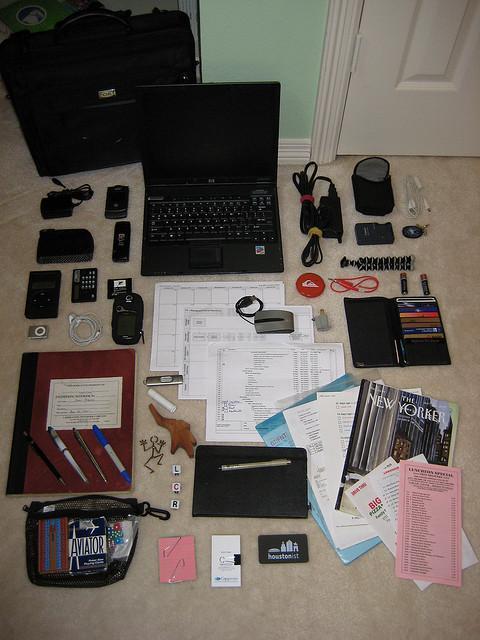How many laptops do you see?
Choose the right answer and clarify with the format: 'Answer: answer
Rationale: rationale.'
Options: None, one, three, two. Answer: one.
Rationale: Though there are several electronic devices present in this image, there is only a single full fledged portable computer with keyboard and monitor attached. 